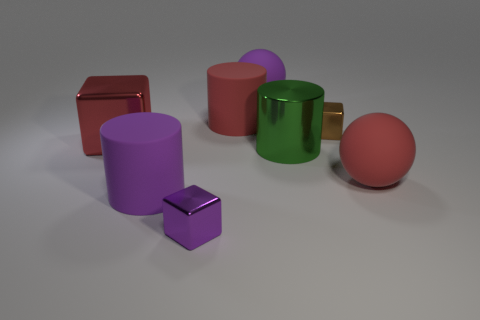What number of red balls are made of the same material as the large red block? There are no red balls that appear to be made of the same material as the large red block. The two objects have different shades and specular qualities, suggesting they are composed of distinct materials. 